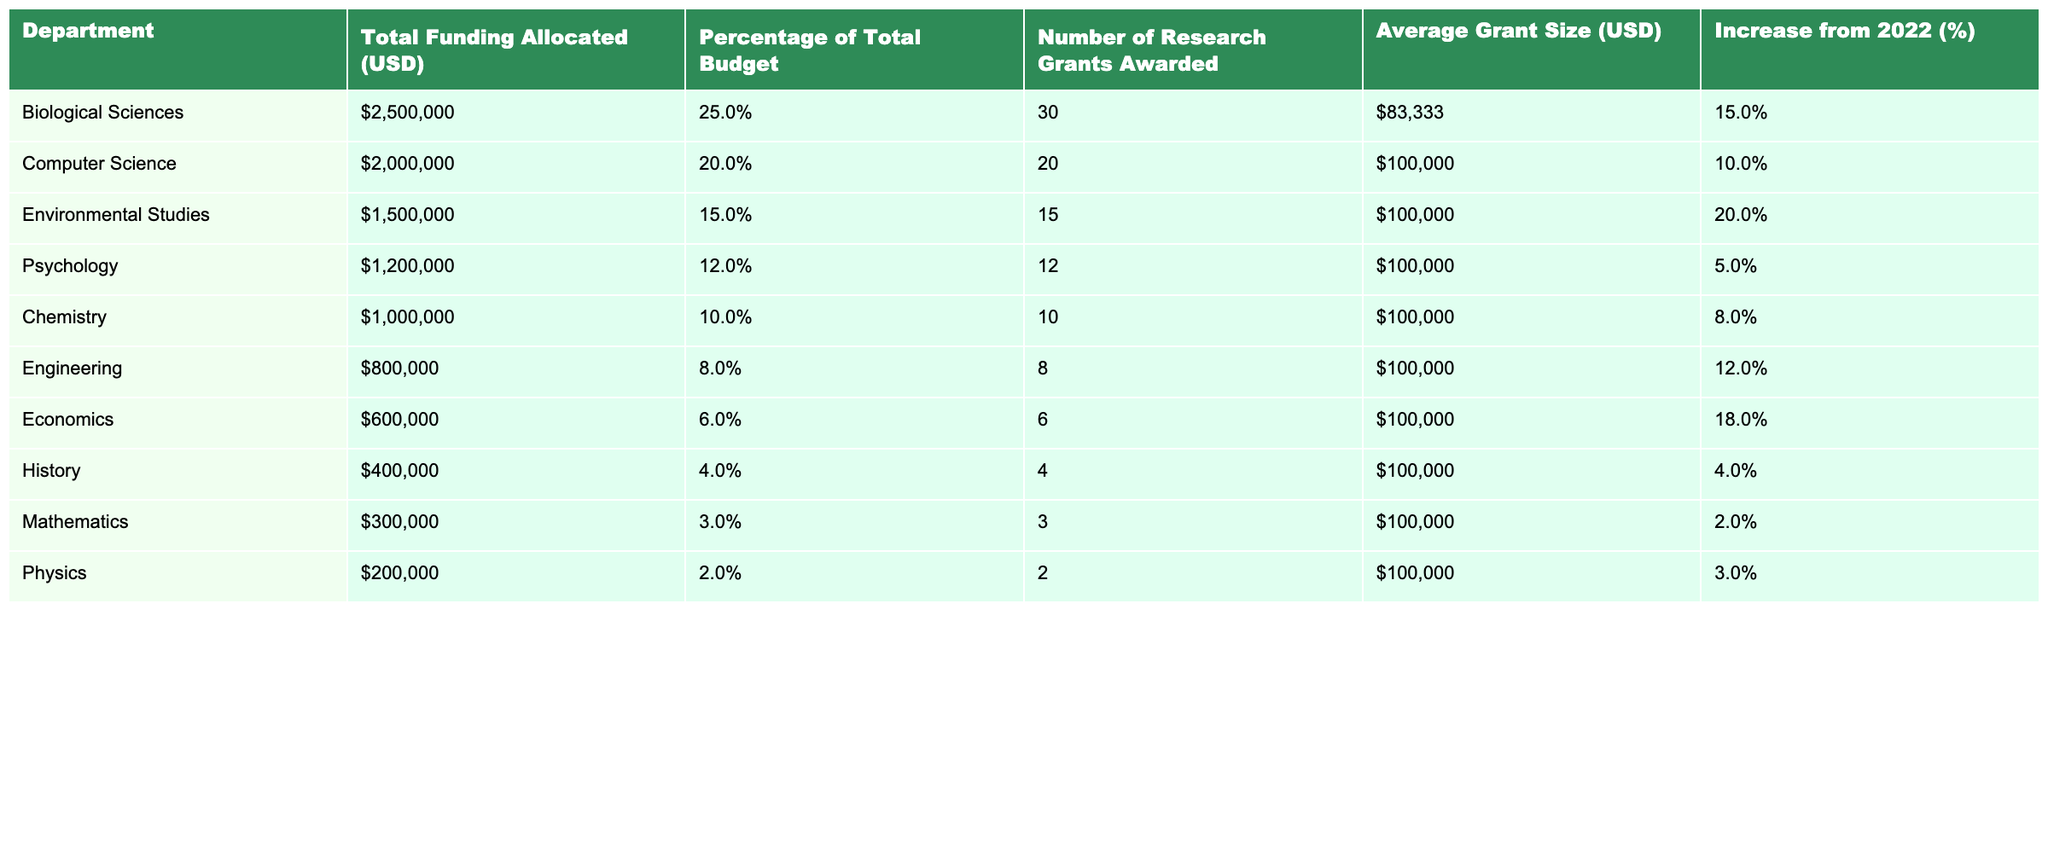What is the total funding allocated to the Biological Sciences department? The table shows that the Total Funding Allocated for the Biological Sciences department is **$2,500,000**.
Answer: $2,500,000 Which department received the lowest total funding allocation? In the table, the department with the lowest total funding allocated is **Mathematics**, with an allocation of **$300,000**.
Answer: Mathematics What is the average grant size awarded to the Environmental Studies department? The table indicates that the Average Grant Size for the Environmental Studies department is **$100,000**.
Answer: $100,000 True or False: The Psychology department received the same average grant size as the Chemistry department. Both the Psychology and Chemistry departments have an Average Grant Size of **$100,000**, therefore this statement is True.
Answer: True Which department had the highest percentage increase from 2022 and what was the percentage increase? The Environmental Studies department experienced the highest increase from 2022 at **20%**, as indicated in the table.
Answer: 20% (Environmental Studies) What is the total funding allocated to the top three departments in terms of funding? The top three departments by funding are Biological Sciences, Computer Science, and Environmental Studies. Adding their allocations gives: $2,500,000 + $2,000,000 + $1,500,000 = $6,000,000.
Answer: $6,000,000 How many research grants were awarded in total across all departments? Summing the Number of Research Grants Awarded from each department: 30 + 20 + 15 + 12 + 10 + 8 + 6 + 4 + 3 + 2 = 110 grants total.
Answer: 110 What percentage of the total budget was allocated to departments that received less than $1,000,000? The departments with less than $1,000,000 are Engineering, Economics, History, Mathematics, and Physics. Their total funding is $800,000 + $600,000 + $400,000 + $300,000 + $200,000 = $2,300,000. The percentage of the total budget is then calculated as (2,300,000 / 10,000,000) * 100 = 23%.
Answer: 23% Which department had the highest average grant size, and what was that size? The department with the highest average grant size is Computer Science, which had an Average Grant Size of **$100,000**.
Answer: Computer Science ($100,000) If the Biological Sciences department were to maintain its percentage of total budget from 2023 in the next funding cycle, and the total budget increases to $10,000,000, what would be their funding allocation? The Biological Sciences department's percentage of total budget for 2023 is **25%**. Thus, if the total budget increases to $10,000,000, the allocation would be $10,000,000 * 0.25 = $2,500,000.
Answer: $2,500,000 